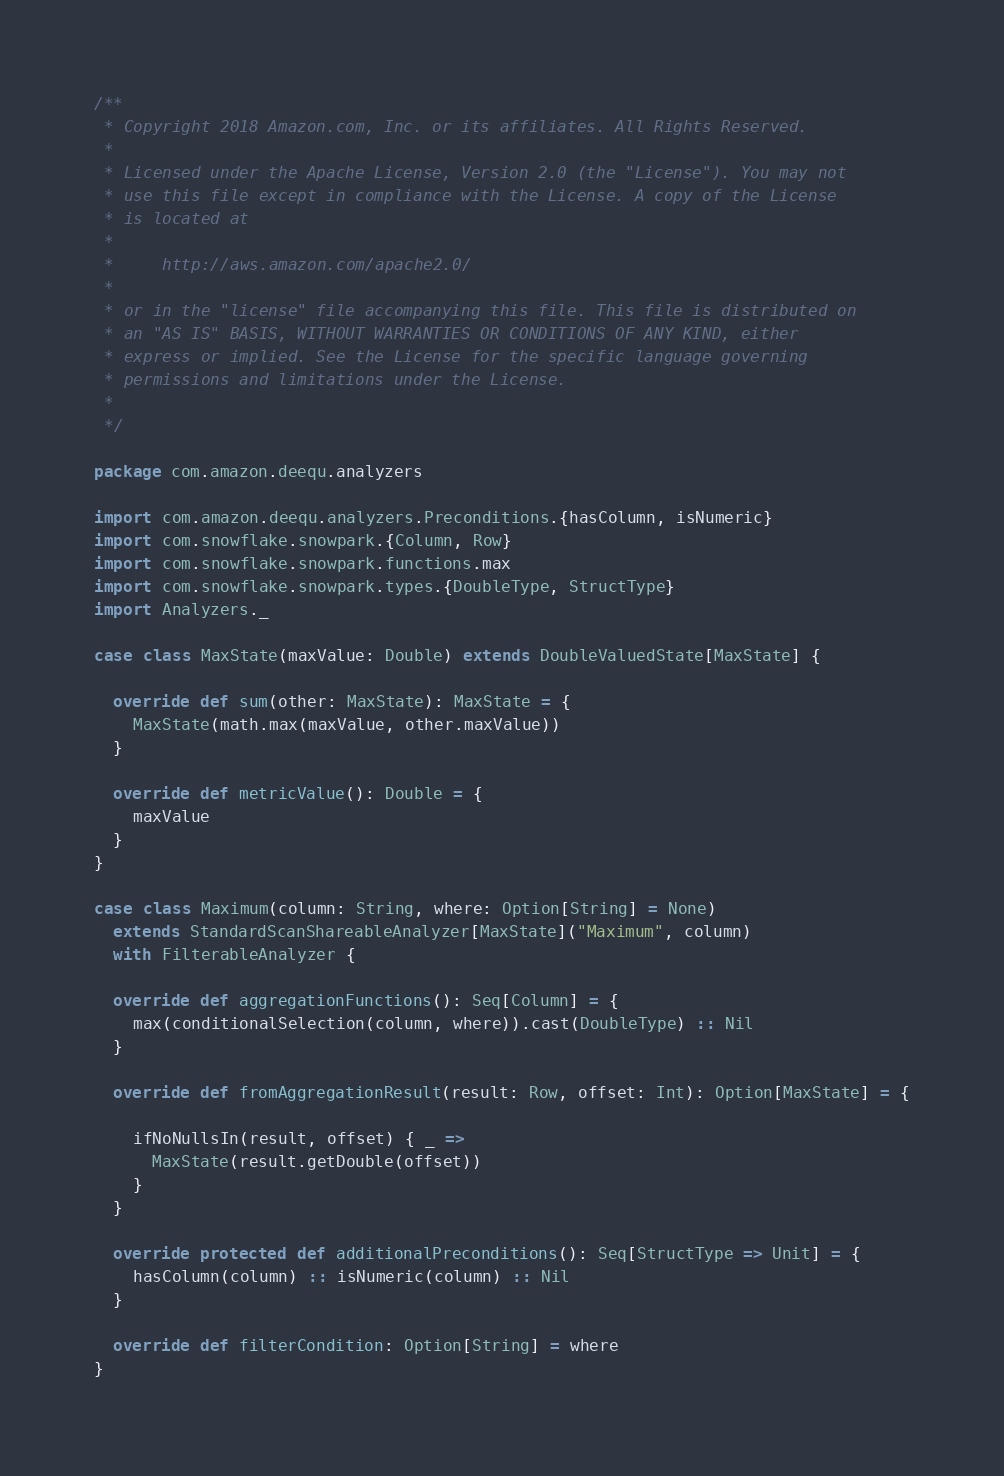Convert code to text. <code><loc_0><loc_0><loc_500><loc_500><_Scala_>/**
 * Copyright 2018 Amazon.com, Inc. or its affiliates. All Rights Reserved.
 *
 * Licensed under the Apache License, Version 2.0 (the "License"). You may not
 * use this file except in compliance with the License. A copy of the License
 * is located at
 *
 *     http://aws.amazon.com/apache2.0/
 *
 * or in the "license" file accompanying this file. This file is distributed on
 * an "AS IS" BASIS, WITHOUT WARRANTIES OR CONDITIONS OF ANY KIND, either
 * express or implied. See the License for the specific language governing
 * permissions and limitations under the License.
 *
 */

package com.amazon.deequ.analyzers

import com.amazon.deequ.analyzers.Preconditions.{hasColumn, isNumeric}
import com.snowflake.snowpark.{Column, Row}
import com.snowflake.snowpark.functions.max
import com.snowflake.snowpark.types.{DoubleType, StructType}
import Analyzers._

case class MaxState(maxValue: Double) extends DoubleValuedState[MaxState] {

  override def sum(other: MaxState): MaxState = {
    MaxState(math.max(maxValue, other.maxValue))
  }

  override def metricValue(): Double = {
    maxValue
  }
}

case class Maximum(column: String, where: Option[String] = None)
  extends StandardScanShareableAnalyzer[MaxState]("Maximum", column)
  with FilterableAnalyzer {

  override def aggregationFunctions(): Seq[Column] = {
    max(conditionalSelection(column, where)).cast(DoubleType) :: Nil
  }

  override def fromAggregationResult(result: Row, offset: Int): Option[MaxState] = {

    ifNoNullsIn(result, offset) { _ =>
      MaxState(result.getDouble(offset))
    }
  }

  override protected def additionalPreconditions(): Seq[StructType => Unit] = {
    hasColumn(column) :: isNumeric(column) :: Nil
  }

  override def filterCondition: Option[String] = where
}
</code> 